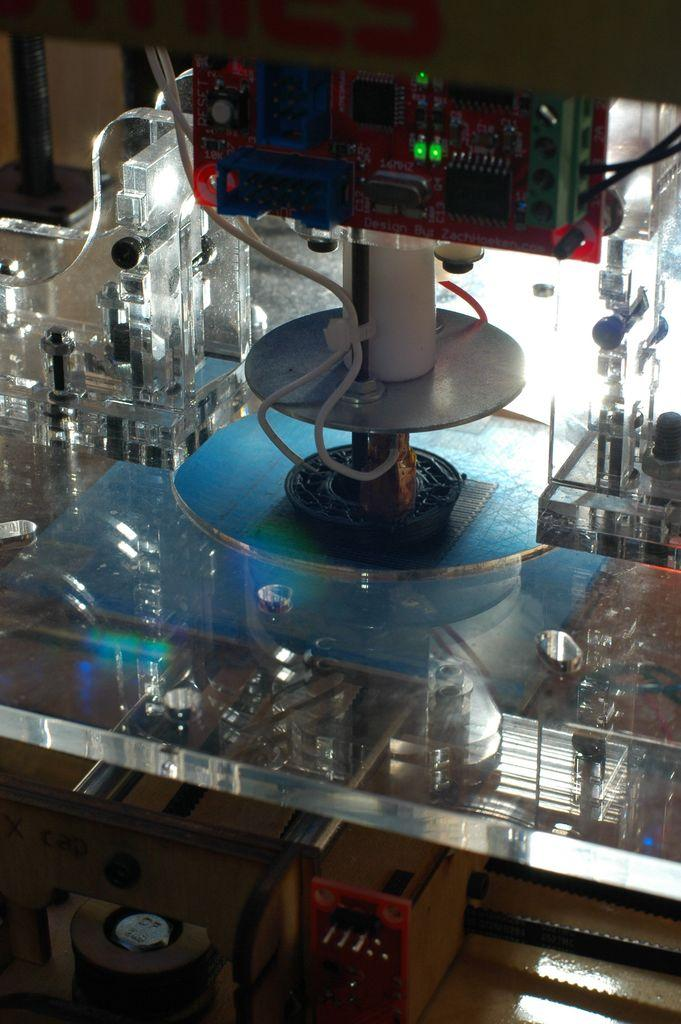What type of electronic device is in the image? The electronic device in the image is not specified, but it has a stand. How is the electronic device positioned in the image? The electronic device is placed on a glass table. Are there any visible wires connected to the electronic device? Yes, there are wires in the image, and they are white in color. What role does the electronic device play in the ongoing battle in the image? There is no battle present in the image, and the electronic device's function is not specified. 